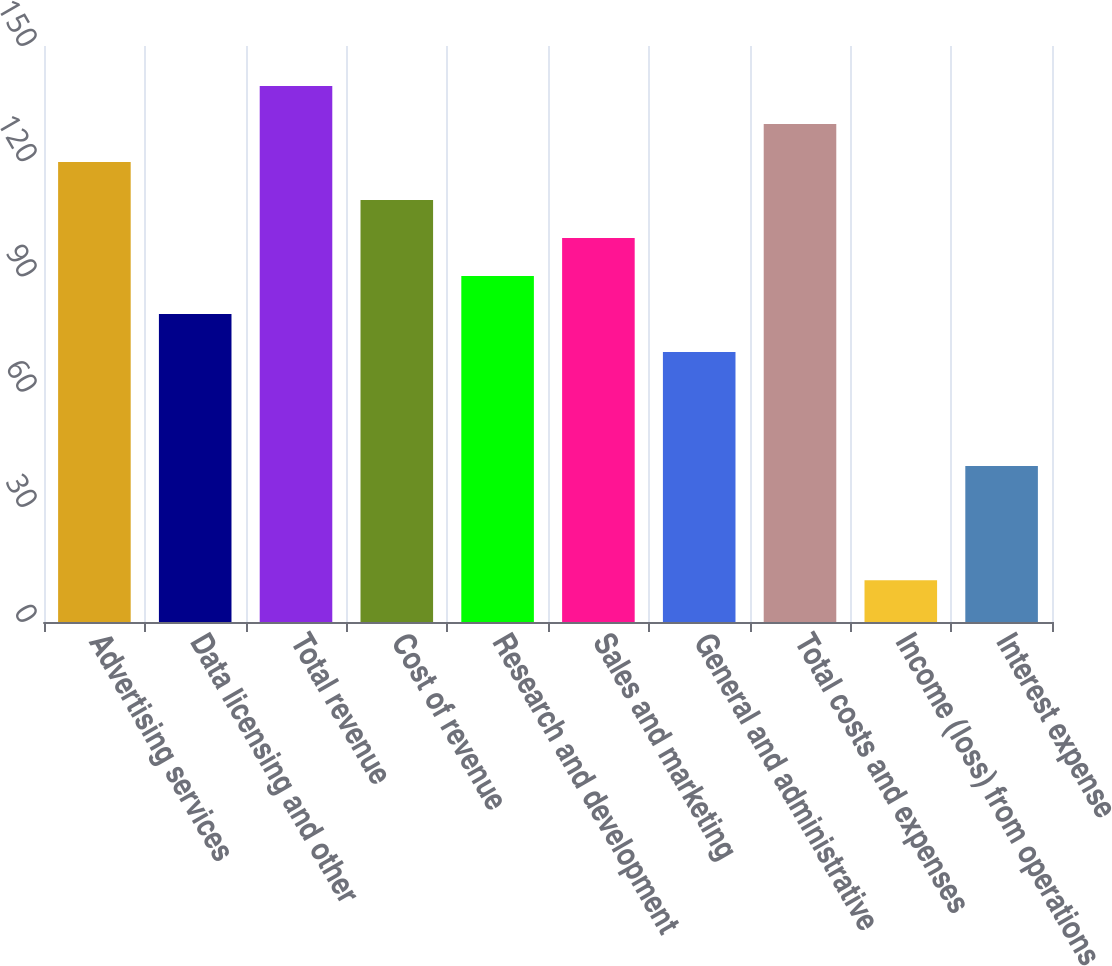Convert chart. <chart><loc_0><loc_0><loc_500><loc_500><bar_chart><fcel>Advertising services<fcel>Data licensing and other<fcel>Total revenue<fcel>Cost of revenue<fcel>Research and development<fcel>Sales and marketing<fcel>General and administrative<fcel>Total costs and expenses<fcel>Income (loss) from operations<fcel>Interest expense<nl><fcel>119.8<fcel>80.2<fcel>139.6<fcel>109.9<fcel>90.1<fcel>100<fcel>70.3<fcel>129.7<fcel>10.9<fcel>40.6<nl></chart> 